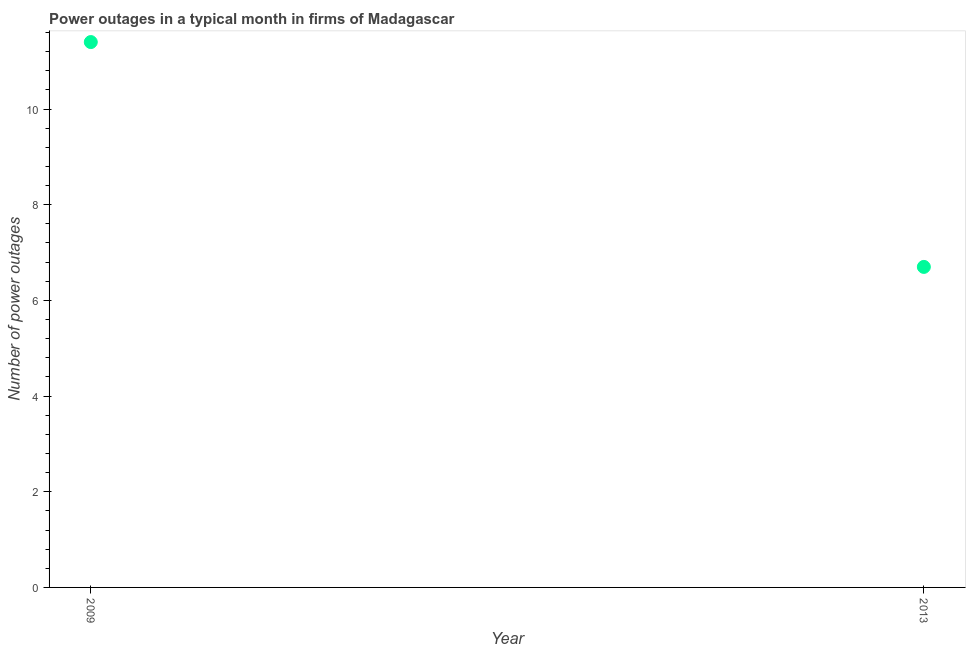Across all years, what is the maximum number of power outages?
Give a very brief answer. 11.4. What is the difference between the number of power outages in 2009 and 2013?
Provide a short and direct response. 4.7. What is the average number of power outages per year?
Ensure brevity in your answer.  9.05. What is the median number of power outages?
Ensure brevity in your answer.  9.05. In how many years, is the number of power outages greater than 4 ?
Your answer should be very brief. 2. Do a majority of the years between 2009 and 2013 (inclusive) have number of power outages greater than 4 ?
Offer a very short reply. Yes. What is the ratio of the number of power outages in 2009 to that in 2013?
Your response must be concise. 1.7. In how many years, is the number of power outages greater than the average number of power outages taken over all years?
Give a very brief answer. 1. How many dotlines are there?
Provide a succinct answer. 1. How many years are there in the graph?
Ensure brevity in your answer.  2. What is the difference between two consecutive major ticks on the Y-axis?
Offer a terse response. 2. Are the values on the major ticks of Y-axis written in scientific E-notation?
Provide a succinct answer. No. Does the graph contain grids?
Keep it short and to the point. No. What is the title of the graph?
Make the answer very short. Power outages in a typical month in firms of Madagascar. What is the label or title of the Y-axis?
Your answer should be very brief. Number of power outages. What is the Number of power outages in 2009?
Your answer should be very brief. 11.4. What is the Number of power outages in 2013?
Provide a succinct answer. 6.7. What is the difference between the Number of power outages in 2009 and 2013?
Offer a very short reply. 4.7. What is the ratio of the Number of power outages in 2009 to that in 2013?
Offer a terse response. 1.7. 